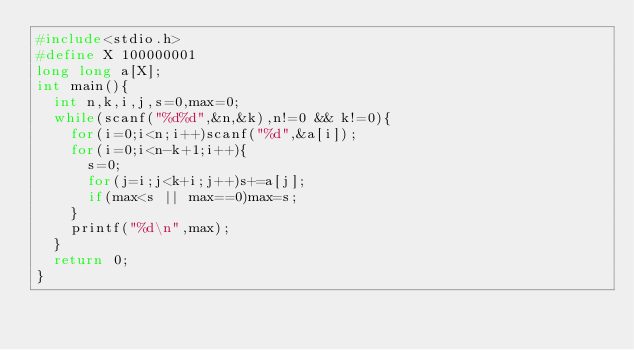<code> <loc_0><loc_0><loc_500><loc_500><_C_>#include<stdio.h>
#define X 100000001
long long a[X];
int main(){
	int n,k,i,j,s=0,max=0;
	while(scanf("%d%d",&n,&k),n!=0 && k!=0){
		for(i=0;i<n;i++)scanf("%d",&a[i]);
		for(i=0;i<n-k+1;i++){
			s=0;
			for(j=i;j<k+i;j++)s+=a[j];
			if(max<s || max==0)max=s;
		}
		printf("%d\n",max);
	}
	return 0;
}

</code> 